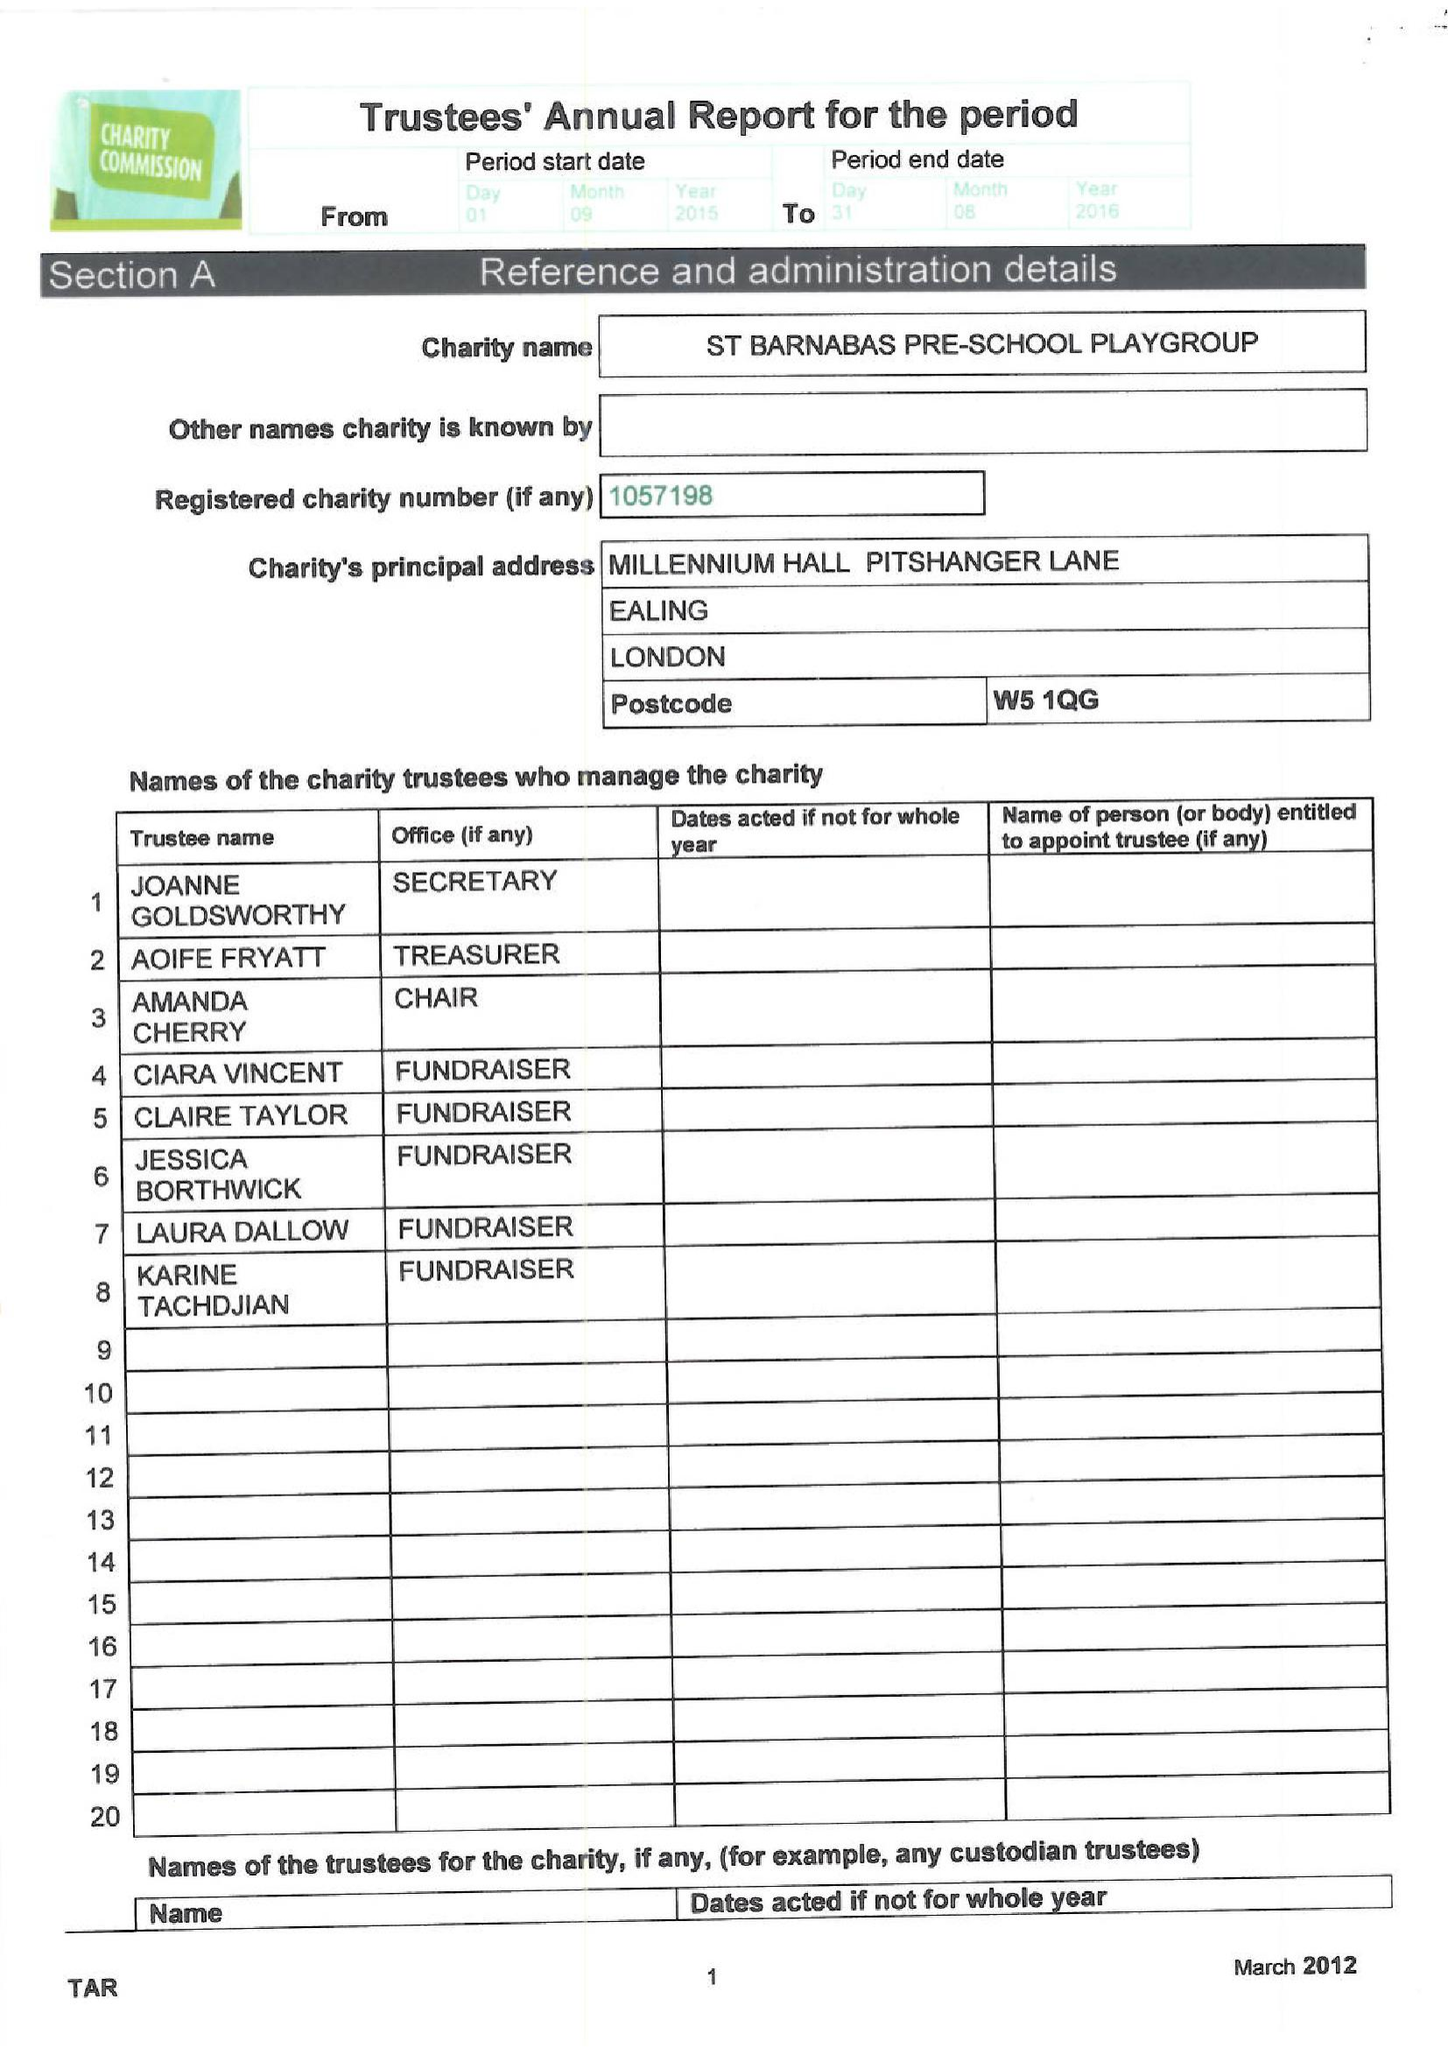What is the value for the charity_number?
Answer the question using a single word or phrase. 1057198 